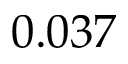<formula> <loc_0><loc_0><loc_500><loc_500>0 . 0 3 7</formula> 